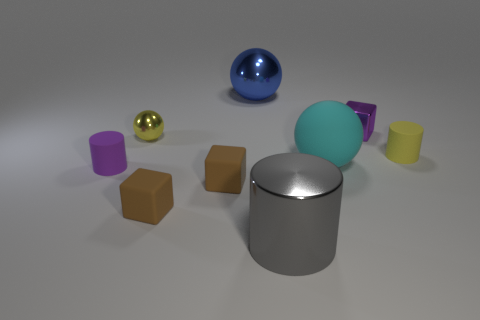Subtract all purple cubes. Subtract all purple cylinders. How many cubes are left? 2 Add 1 small purple metal objects. How many objects exist? 10 Subtract all brown cylinders. Subtract all tiny purple rubber cylinders. How many objects are left? 8 Add 4 matte spheres. How many matte spheres are left? 5 Add 1 red spheres. How many red spheres exist? 1 Subtract 0 green spheres. How many objects are left? 9 Subtract all spheres. How many objects are left? 6 